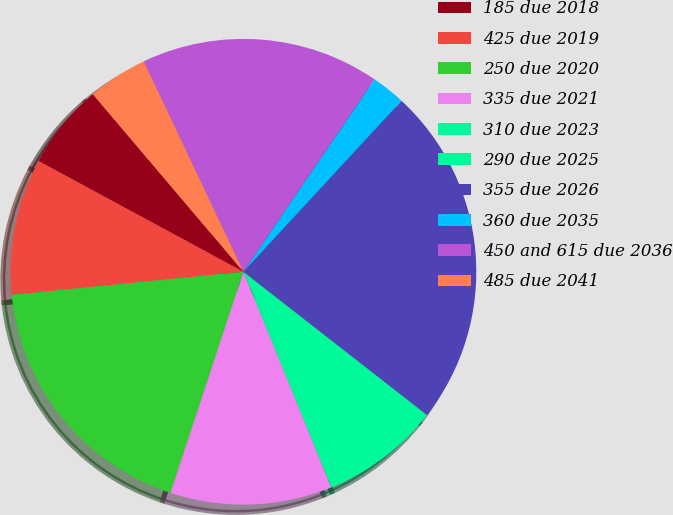Convert chart. <chart><loc_0><loc_0><loc_500><loc_500><pie_chart><fcel>185 due 2018<fcel>425 due 2019<fcel>250 due 2020<fcel>335 due 2021<fcel>310 due 2023<fcel>290 due 2025<fcel>355 due 2026<fcel>360 due 2035<fcel>450 and 615 due 2036<fcel>485 due 2041<nl><fcel>5.92%<fcel>9.47%<fcel>18.34%<fcel>11.24%<fcel>0.6%<fcel>7.69%<fcel>23.66%<fcel>2.37%<fcel>16.56%<fcel>4.15%<nl></chart> 